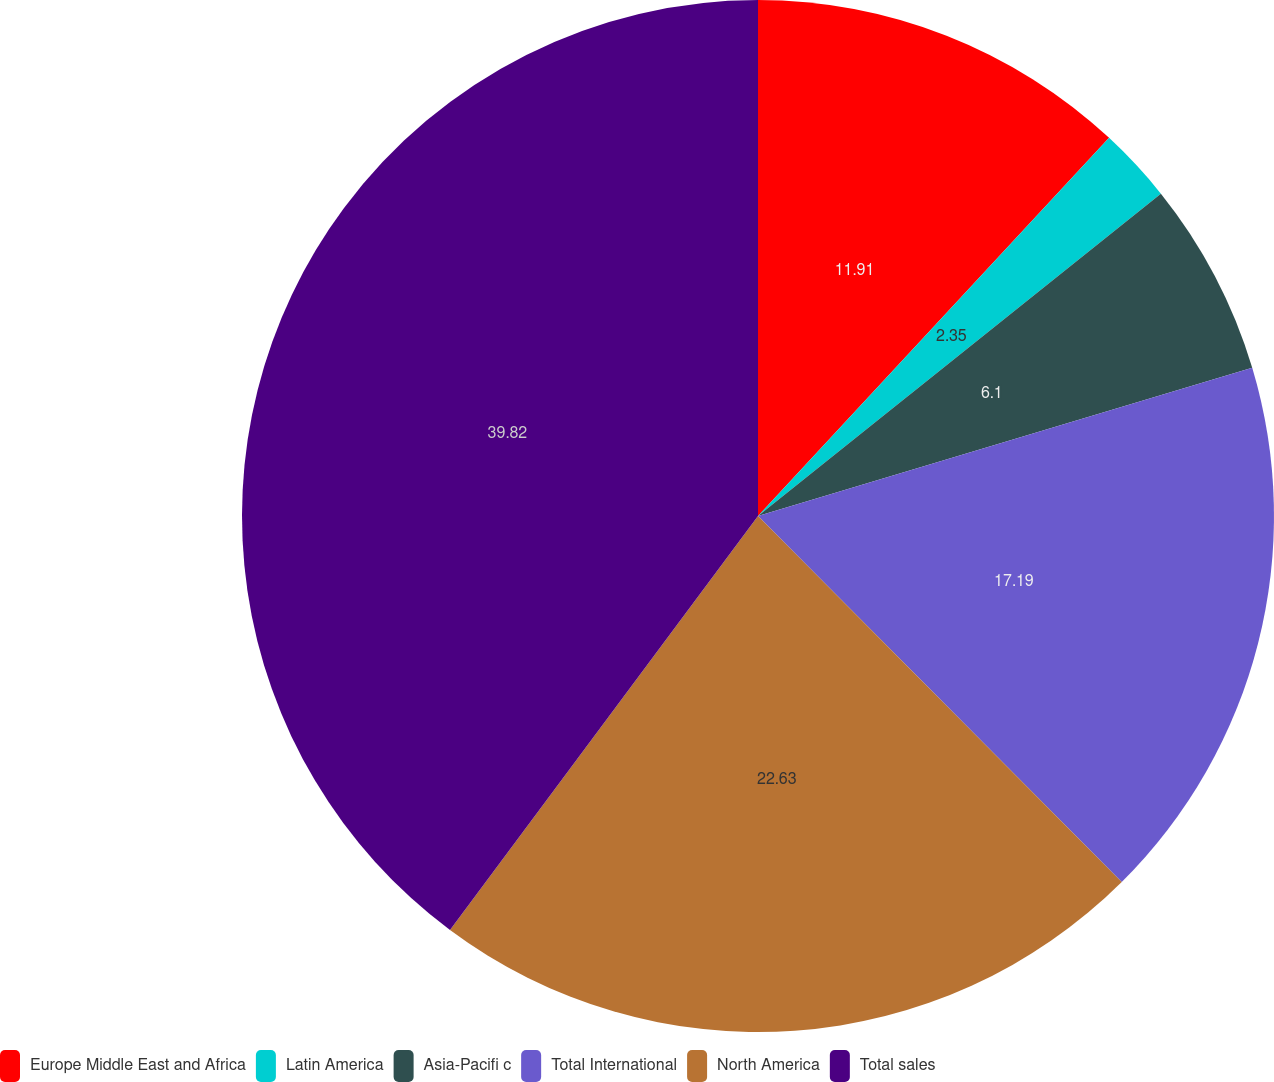Convert chart to OTSL. <chart><loc_0><loc_0><loc_500><loc_500><pie_chart><fcel>Europe Middle East and Africa<fcel>Latin America<fcel>Asia-Pacifi c<fcel>Total International<fcel>North America<fcel>Total sales<nl><fcel>11.91%<fcel>2.35%<fcel>6.1%<fcel>17.19%<fcel>22.63%<fcel>39.82%<nl></chart> 